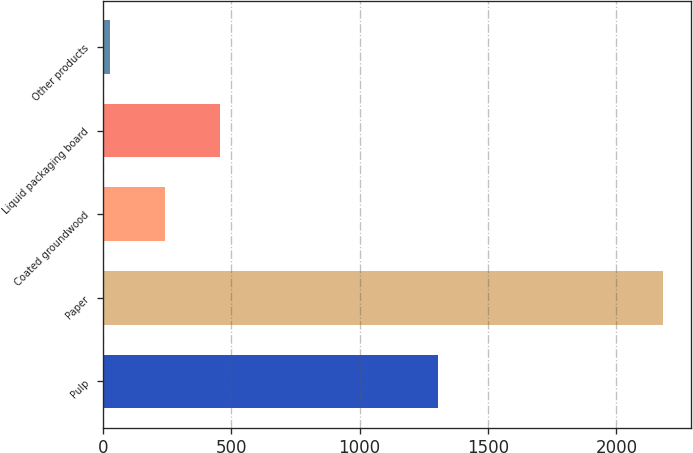<chart> <loc_0><loc_0><loc_500><loc_500><bar_chart><fcel>Pulp<fcel>Paper<fcel>Coated groundwood<fcel>Liquid packaging board<fcel>Other products<nl><fcel>1305<fcel>2182<fcel>241.6<fcel>457.2<fcel>26<nl></chart> 